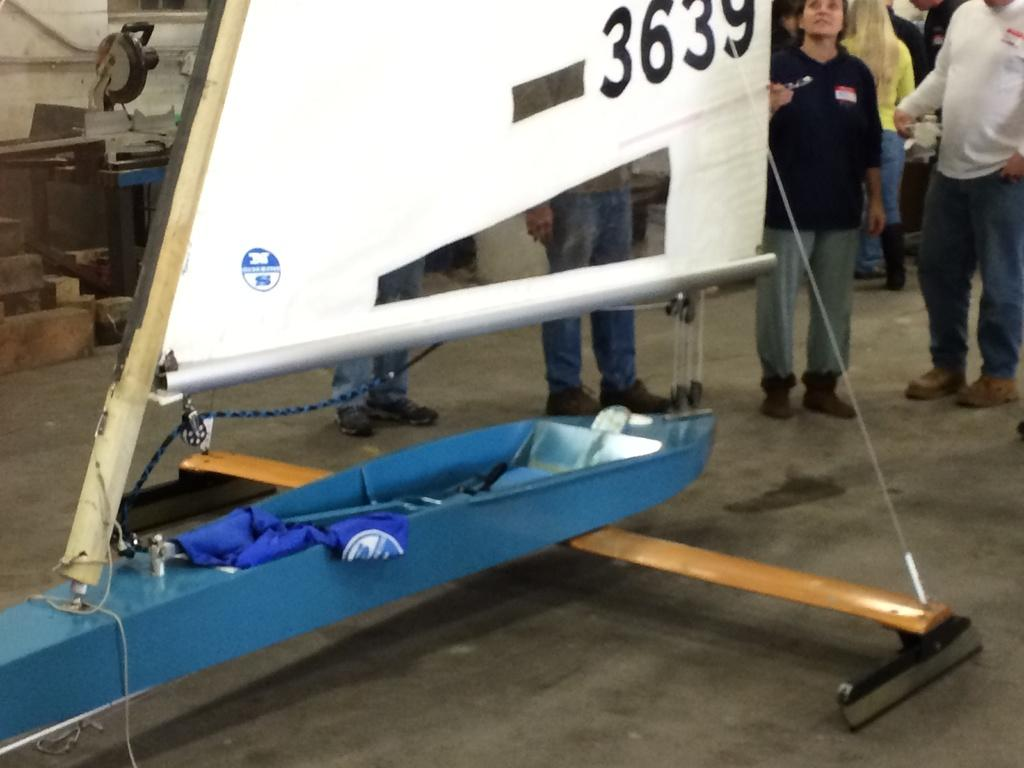<image>
Relay a brief, clear account of the picture shown. A thin blue boat with a sail numbered 3639 is indoors and people are looking at it. 